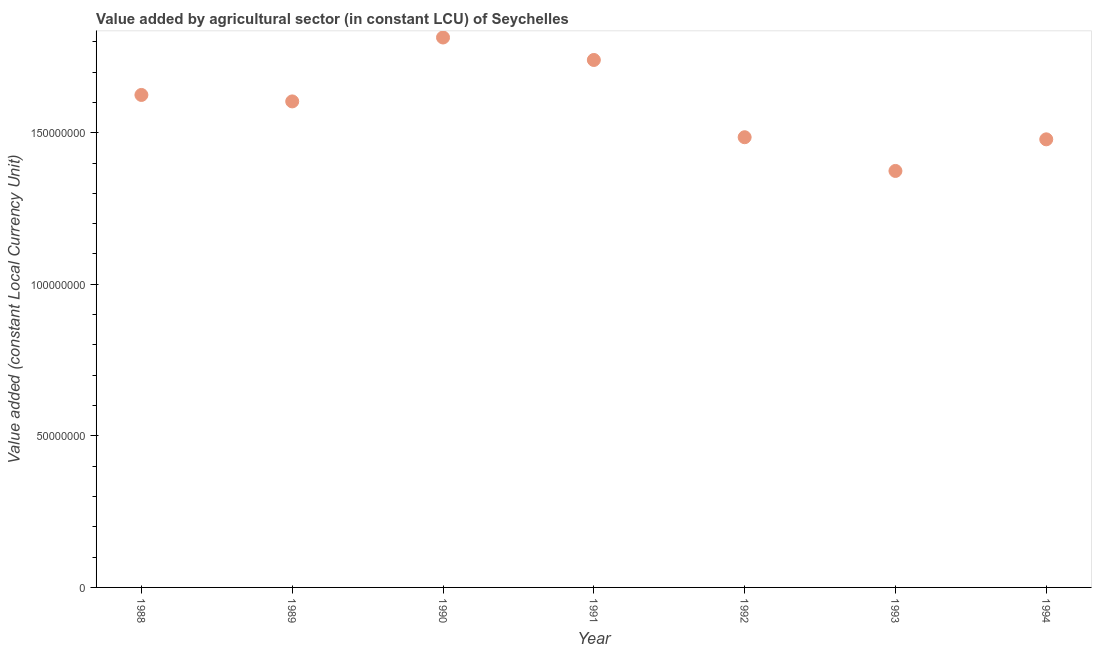What is the value added by agriculture sector in 1988?
Ensure brevity in your answer.  1.62e+08. Across all years, what is the maximum value added by agriculture sector?
Offer a very short reply. 1.81e+08. Across all years, what is the minimum value added by agriculture sector?
Offer a terse response. 1.37e+08. In which year was the value added by agriculture sector minimum?
Your response must be concise. 1993. What is the sum of the value added by agriculture sector?
Give a very brief answer. 1.11e+09. What is the difference between the value added by agriculture sector in 1988 and 1993?
Make the answer very short. 2.51e+07. What is the average value added by agriculture sector per year?
Make the answer very short. 1.59e+08. What is the median value added by agriculture sector?
Your answer should be compact. 1.60e+08. In how many years, is the value added by agriculture sector greater than 80000000 LCU?
Provide a succinct answer. 7. Do a majority of the years between 1990 and 1991 (inclusive) have value added by agriculture sector greater than 140000000 LCU?
Provide a short and direct response. Yes. What is the ratio of the value added by agriculture sector in 1988 to that in 1989?
Provide a succinct answer. 1.01. Is the value added by agriculture sector in 1989 less than that in 1992?
Your answer should be very brief. No. What is the difference between the highest and the second highest value added by agriculture sector?
Your answer should be compact. 7.41e+06. What is the difference between the highest and the lowest value added by agriculture sector?
Provide a succinct answer. 4.40e+07. In how many years, is the value added by agriculture sector greater than the average value added by agriculture sector taken over all years?
Give a very brief answer. 4. Does the value added by agriculture sector monotonically increase over the years?
Provide a succinct answer. No. What is the difference between two consecutive major ticks on the Y-axis?
Give a very brief answer. 5.00e+07. Does the graph contain any zero values?
Provide a short and direct response. No. Does the graph contain grids?
Ensure brevity in your answer.  No. What is the title of the graph?
Provide a short and direct response. Value added by agricultural sector (in constant LCU) of Seychelles. What is the label or title of the Y-axis?
Provide a succinct answer. Value added (constant Local Currency Unit). What is the Value added (constant Local Currency Unit) in 1988?
Provide a succinct answer. 1.62e+08. What is the Value added (constant Local Currency Unit) in 1989?
Offer a terse response. 1.60e+08. What is the Value added (constant Local Currency Unit) in 1990?
Ensure brevity in your answer.  1.81e+08. What is the Value added (constant Local Currency Unit) in 1991?
Keep it short and to the point. 1.74e+08. What is the Value added (constant Local Currency Unit) in 1992?
Offer a terse response. 1.49e+08. What is the Value added (constant Local Currency Unit) in 1993?
Keep it short and to the point. 1.37e+08. What is the Value added (constant Local Currency Unit) in 1994?
Offer a very short reply. 1.48e+08. What is the difference between the Value added (constant Local Currency Unit) in 1988 and 1989?
Ensure brevity in your answer.  2.13e+06. What is the difference between the Value added (constant Local Currency Unit) in 1988 and 1990?
Offer a very short reply. -1.90e+07. What is the difference between the Value added (constant Local Currency Unit) in 1988 and 1991?
Offer a very short reply. -1.15e+07. What is the difference between the Value added (constant Local Currency Unit) in 1988 and 1992?
Provide a short and direct response. 1.39e+07. What is the difference between the Value added (constant Local Currency Unit) in 1988 and 1993?
Provide a short and direct response. 2.51e+07. What is the difference between the Value added (constant Local Currency Unit) in 1988 and 1994?
Offer a terse response. 1.46e+07. What is the difference between the Value added (constant Local Currency Unit) in 1989 and 1990?
Your answer should be compact. -2.11e+07. What is the difference between the Value added (constant Local Currency Unit) in 1989 and 1991?
Keep it short and to the point. -1.37e+07. What is the difference between the Value added (constant Local Currency Unit) in 1989 and 1992?
Keep it short and to the point. 1.18e+07. What is the difference between the Value added (constant Local Currency Unit) in 1989 and 1993?
Keep it short and to the point. 2.29e+07. What is the difference between the Value added (constant Local Currency Unit) in 1989 and 1994?
Make the answer very short. 1.25e+07. What is the difference between the Value added (constant Local Currency Unit) in 1990 and 1991?
Your answer should be very brief. 7.41e+06. What is the difference between the Value added (constant Local Currency Unit) in 1990 and 1992?
Provide a short and direct response. 3.29e+07. What is the difference between the Value added (constant Local Currency Unit) in 1990 and 1993?
Make the answer very short. 4.40e+07. What is the difference between the Value added (constant Local Currency Unit) in 1990 and 1994?
Your answer should be compact. 3.36e+07. What is the difference between the Value added (constant Local Currency Unit) in 1991 and 1992?
Provide a succinct answer. 2.55e+07. What is the difference between the Value added (constant Local Currency Unit) in 1991 and 1993?
Provide a succinct answer. 3.66e+07. What is the difference between the Value added (constant Local Currency Unit) in 1991 and 1994?
Your response must be concise. 2.62e+07. What is the difference between the Value added (constant Local Currency Unit) in 1992 and 1993?
Give a very brief answer. 1.11e+07. What is the difference between the Value added (constant Local Currency Unit) in 1992 and 1994?
Ensure brevity in your answer.  6.95e+05. What is the difference between the Value added (constant Local Currency Unit) in 1993 and 1994?
Offer a terse response. -1.04e+07. What is the ratio of the Value added (constant Local Currency Unit) in 1988 to that in 1990?
Ensure brevity in your answer.  0.9. What is the ratio of the Value added (constant Local Currency Unit) in 1988 to that in 1991?
Keep it short and to the point. 0.93. What is the ratio of the Value added (constant Local Currency Unit) in 1988 to that in 1992?
Offer a terse response. 1.09. What is the ratio of the Value added (constant Local Currency Unit) in 1988 to that in 1993?
Provide a short and direct response. 1.18. What is the ratio of the Value added (constant Local Currency Unit) in 1988 to that in 1994?
Provide a short and direct response. 1.1. What is the ratio of the Value added (constant Local Currency Unit) in 1989 to that in 1990?
Offer a terse response. 0.88. What is the ratio of the Value added (constant Local Currency Unit) in 1989 to that in 1991?
Keep it short and to the point. 0.92. What is the ratio of the Value added (constant Local Currency Unit) in 1989 to that in 1992?
Offer a very short reply. 1.08. What is the ratio of the Value added (constant Local Currency Unit) in 1989 to that in 1993?
Your response must be concise. 1.17. What is the ratio of the Value added (constant Local Currency Unit) in 1989 to that in 1994?
Keep it short and to the point. 1.08. What is the ratio of the Value added (constant Local Currency Unit) in 1990 to that in 1991?
Offer a terse response. 1.04. What is the ratio of the Value added (constant Local Currency Unit) in 1990 to that in 1992?
Provide a succinct answer. 1.22. What is the ratio of the Value added (constant Local Currency Unit) in 1990 to that in 1993?
Your response must be concise. 1.32. What is the ratio of the Value added (constant Local Currency Unit) in 1990 to that in 1994?
Ensure brevity in your answer.  1.23. What is the ratio of the Value added (constant Local Currency Unit) in 1991 to that in 1992?
Offer a very short reply. 1.17. What is the ratio of the Value added (constant Local Currency Unit) in 1991 to that in 1993?
Offer a terse response. 1.27. What is the ratio of the Value added (constant Local Currency Unit) in 1991 to that in 1994?
Give a very brief answer. 1.18. What is the ratio of the Value added (constant Local Currency Unit) in 1992 to that in 1993?
Your answer should be compact. 1.08. What is the ratio of the Value added (constant Local Currency Unit) in 1993 to that in 1994?
Your answer should be very brief. 0.93. 